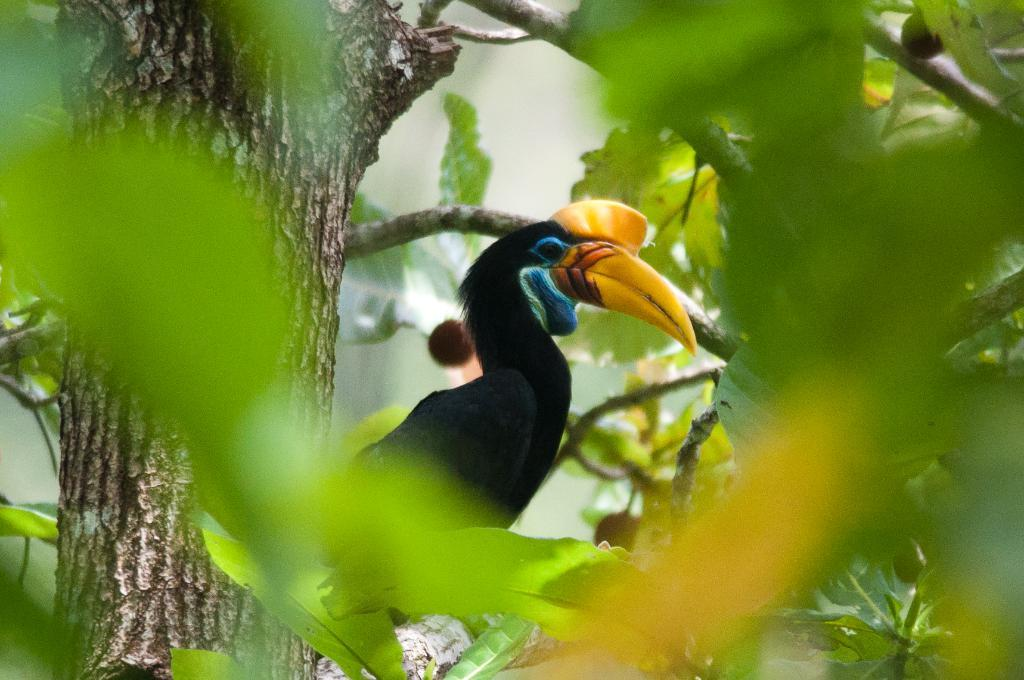What type of animal is in the image? There is a bird in the image. What color is the bird? The bird is black. What color is the bird's beak? The bird's beak is yellow. Where is the bird sitting? The bird is sitting on a tree. What can be seen on the tree around the bird? There are green leaves on the left and right of the bird. How would you describe the background of the image? The background of the image is blurred. What type of lead can be seen on the bird's feet in the image? There is no lead present on the bird's feet in the image. Is there a gun visible in the image? There is no gun present in the image. 